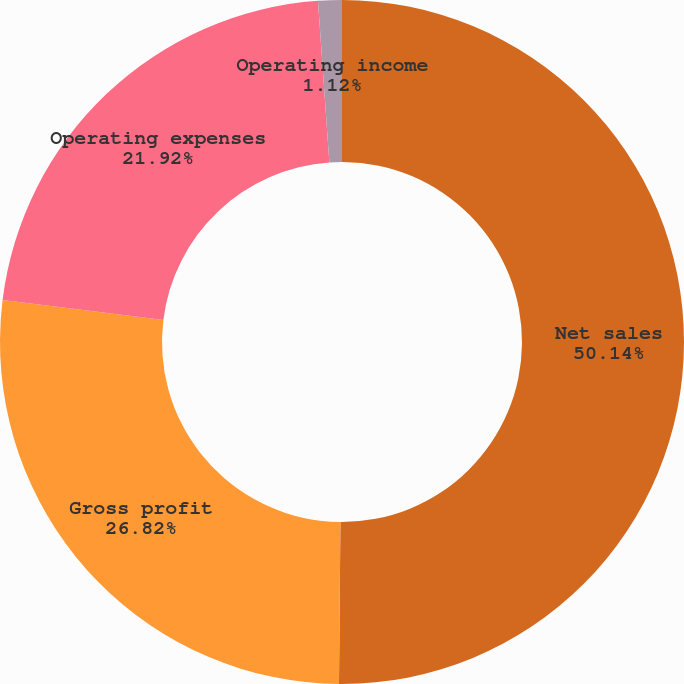Convert chart to OTSL. <chart><loc_0><loc_0><loc_500><loc_500><pie_chart><fcel>Net sales<fcel>Gross profit<fcel>Operating expenses<fcel>Operating income<nl><fcel>50.14%<fcel>26.82%<fcel>21.92%<fcel>1.12%<nl></chart> 